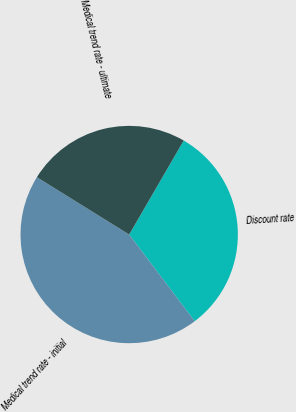Convert chart. <chart><loc_0><loc_0><loc_500><loc_500><pie_chart><fcel>Discount rate<fcel>Medical trend rate - initial<fcel>Medical trend rate - ultimate<nl><fcel>31.34%<fcel>44.14%<fcel>24.52%<nl></chart> 